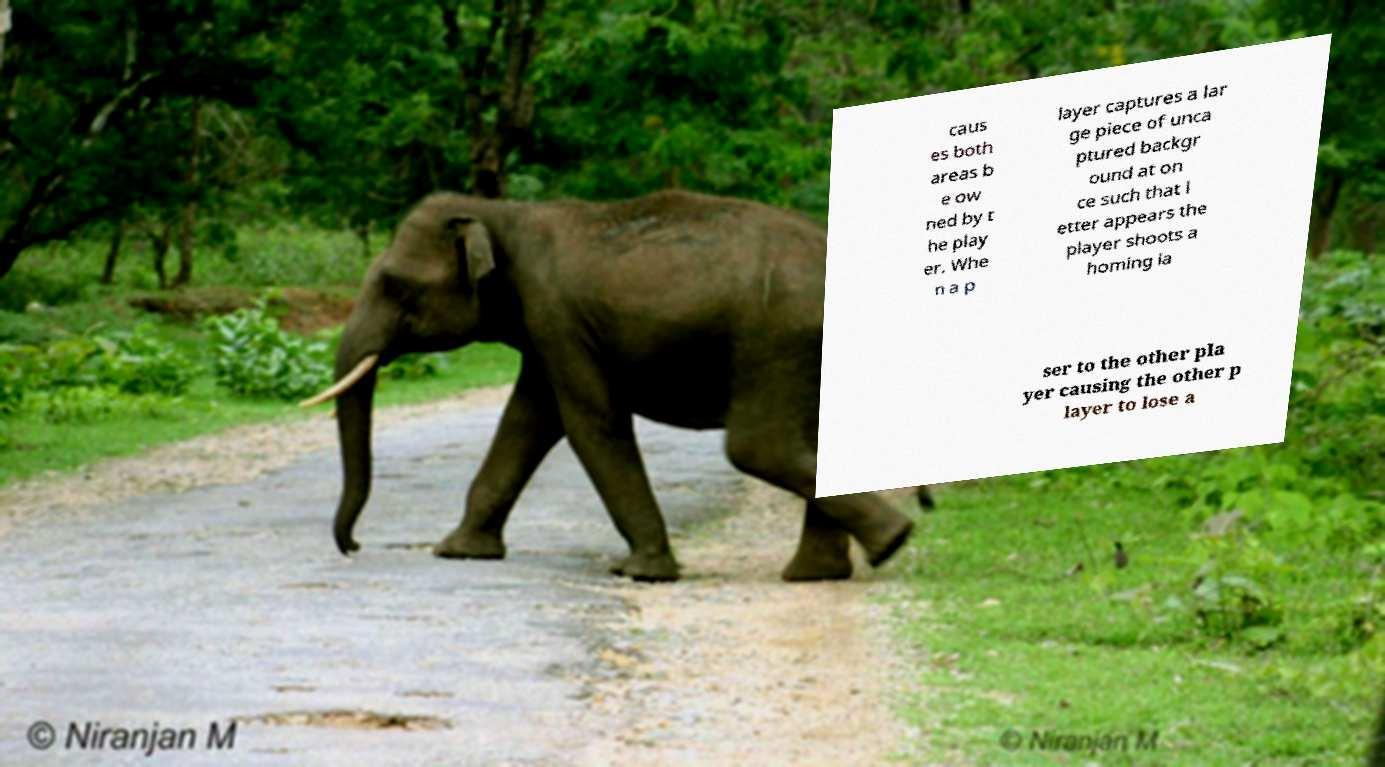Can you accurately transcribe the text from the provided image for me? caus es both areas b e ow ned by t he play er. Whe n a p layer captures a lar ge piece of unca ptured backgr ound at on ce such that l etter appears the player shoots a homing la ser to the other pla yer causing the other p layer to lose a 